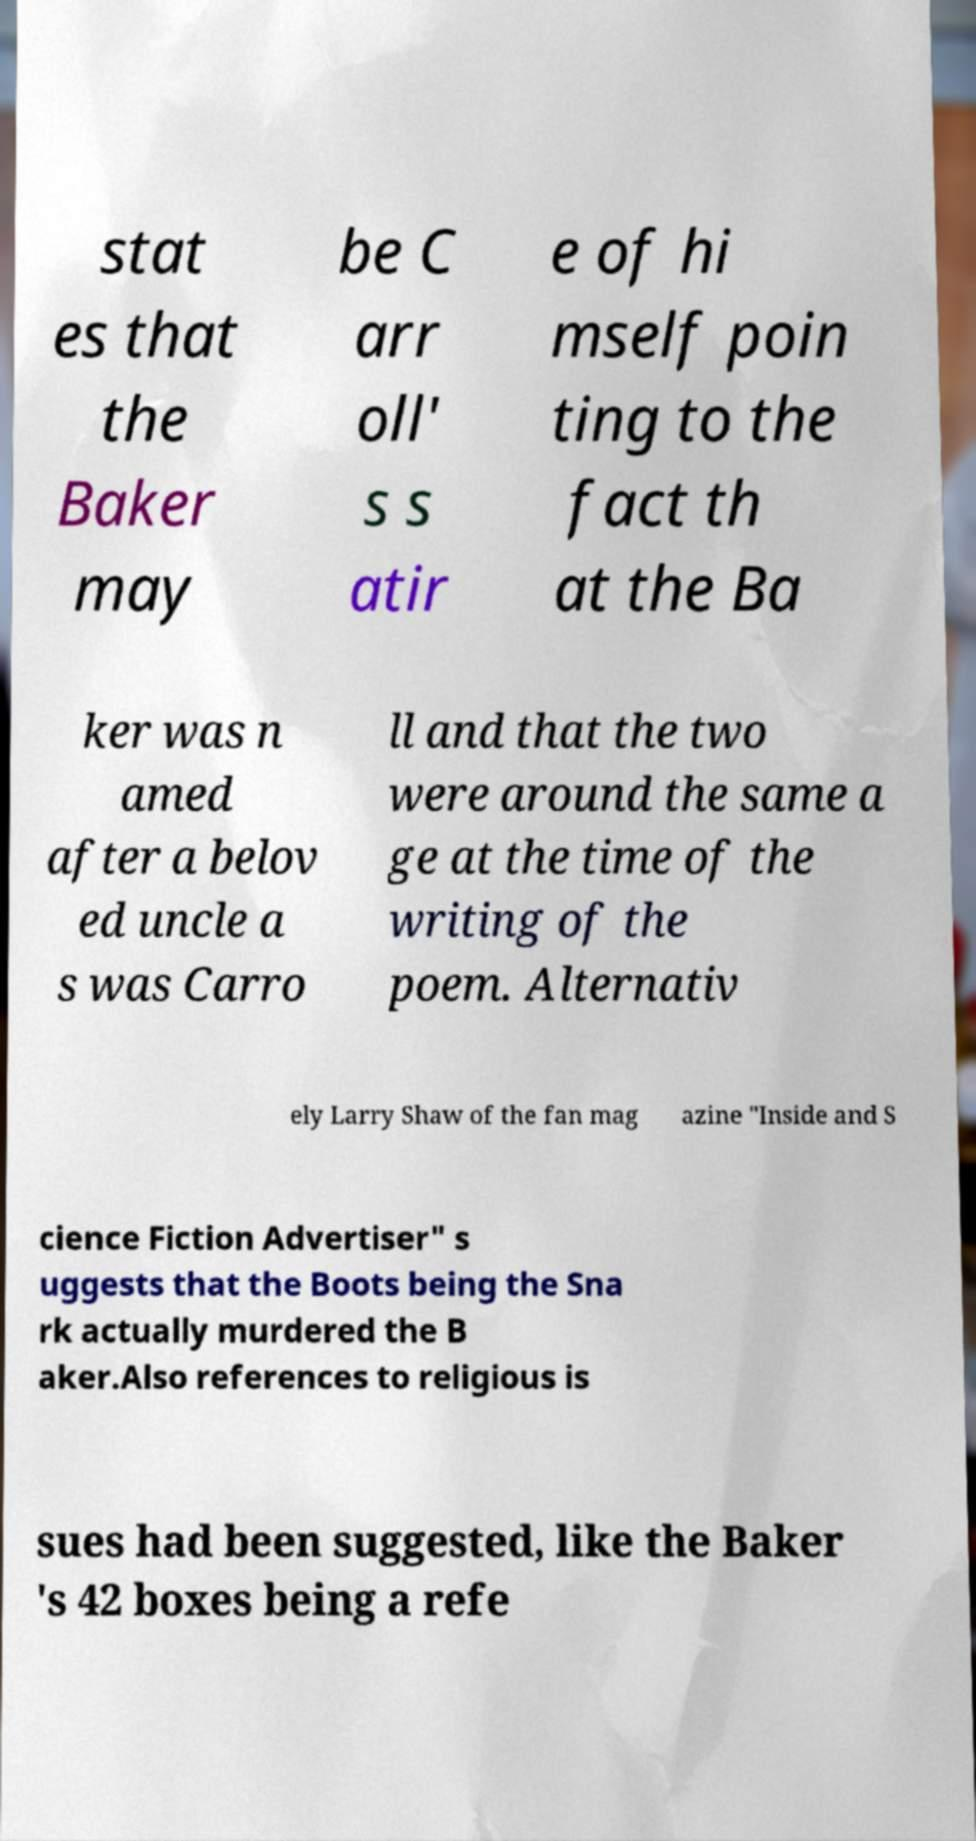Please identify and transcribe the text found in this image. stat es that the Baker may be C arr oll' s s atir e of hi mself poin ting to the fact th at the Ba ker was n amed after a belov ed uncle a s was Carro ll and that the two were around the same a ge at the time of the writing of the poem. Alternativ ely Larry Shaw of the fan mag azine "Inside and S cience Fiction Advertiser" s uggests that the Boots being the Sna rk actually murdered the B aker.Also references to religious is sues had been suggested, like the Baker 's 42 boxes being a refe 